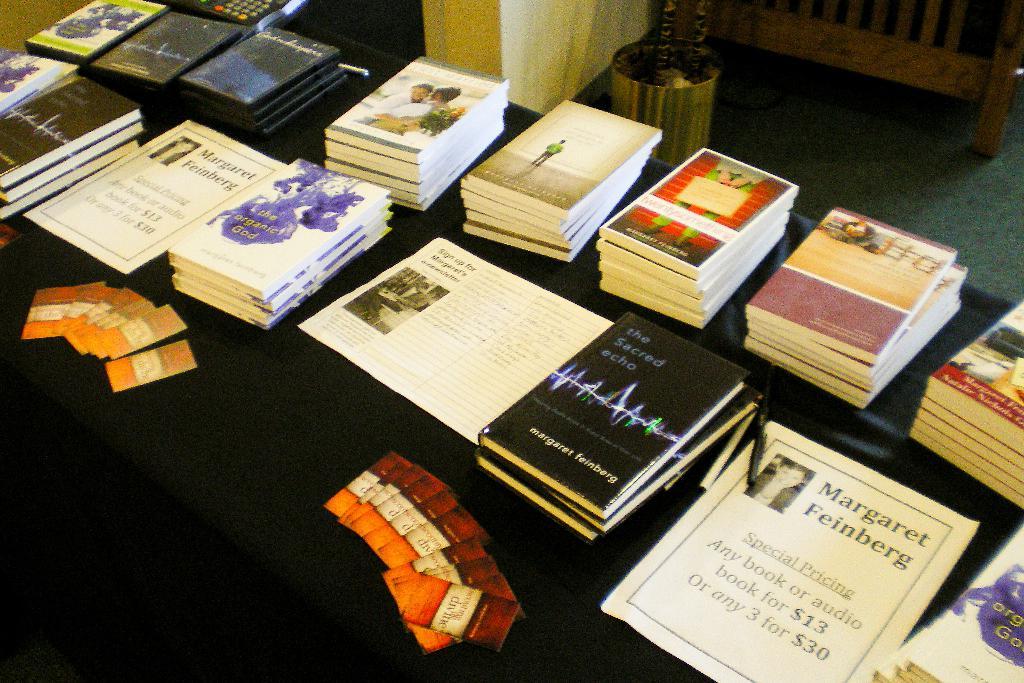Are all the books the same titles ?
Make the answer very short. No. What is the titel of the black book?
Ensure brevity in your answer.  The sacred echo. 